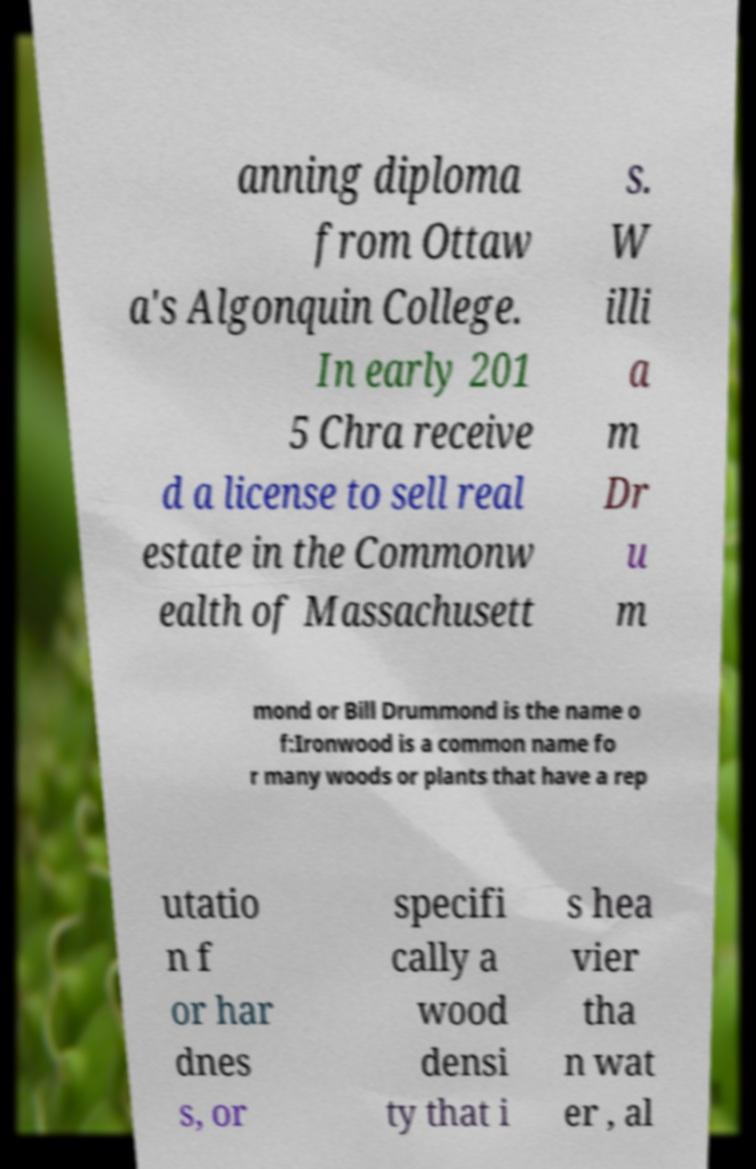Could you extract and type out the text from this image? anning diploma from Ottaw a's Algonquin College. In early 201 5 Chra receive d a license to sell real estate in the Commonw ealth of Massachusett s. W illi a m Dr u m mond or Bill Drummond is the name o f:Ironwood is a common name fo r many woods or plants that have a rep utatio n f or har dnes s, or specifi cally a wood densi ty that i s hea vier tha n wat er , al 